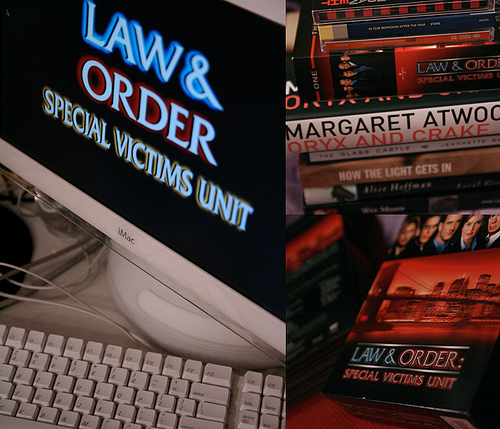<image>What game console sponsors this event? It is ambiguous which game console sponsors this event, it can be either 'xbox' or 'imac'. What game console sponsors this event? I am not sure which game console sponsors this event. It can be seen 'law and order', 'mac', 'xbox' or 'imac'. 